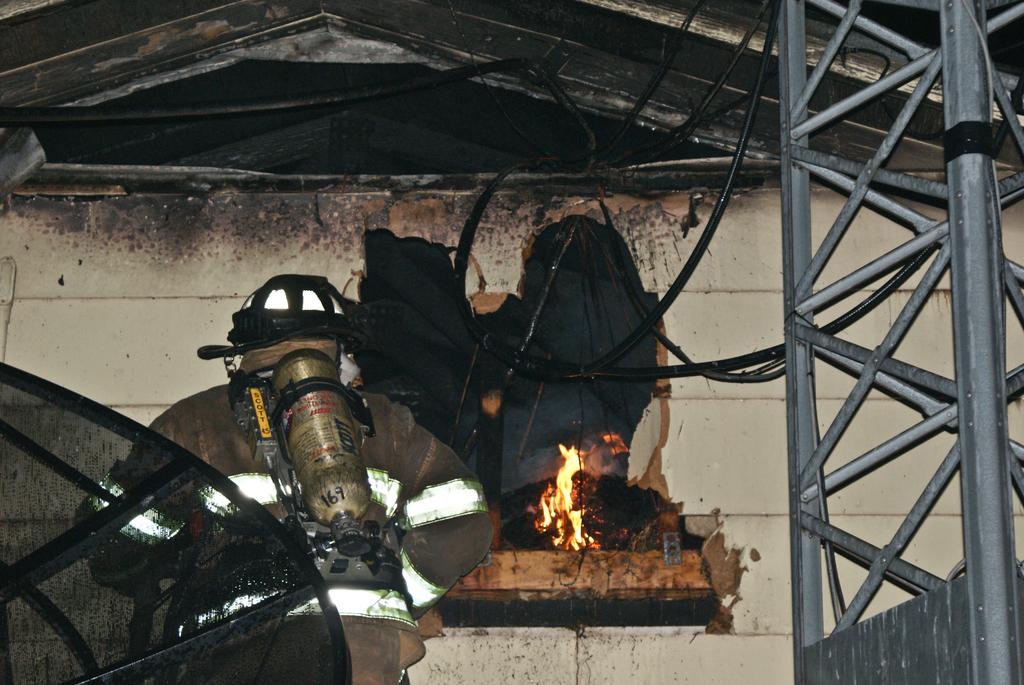Describe this image in one or two sentences. In the image we can see there is a electrical machine kept close to the wall and there is a fire place on top of the wall. Beside there is an iron poles tower. 